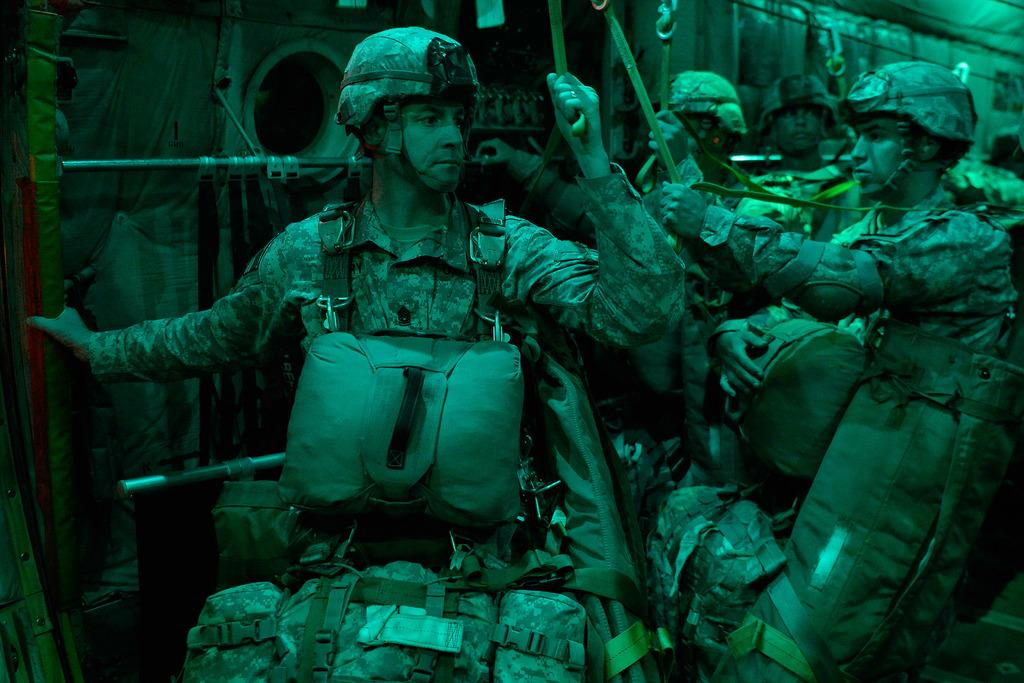How many people are in the image? There are people in the image, but the exact number is not specified. What are the people wearing on their heads? The people are wearing helmets. What are the people holding in their hands? The people are holding belts. What can be seen attached to the walls in the image? There are hooks visible in the image. What type of items can be seen in the image? There are bags and belts visible in the image. What else can be seen in the image besides the people and their belongings? There are rods visible in the image. What type of home can be seen in the background of the image? There is no home visible in the image. How many sacks are being carried by the people in the image? There are no sacks present in the image; the people are holding belts. 